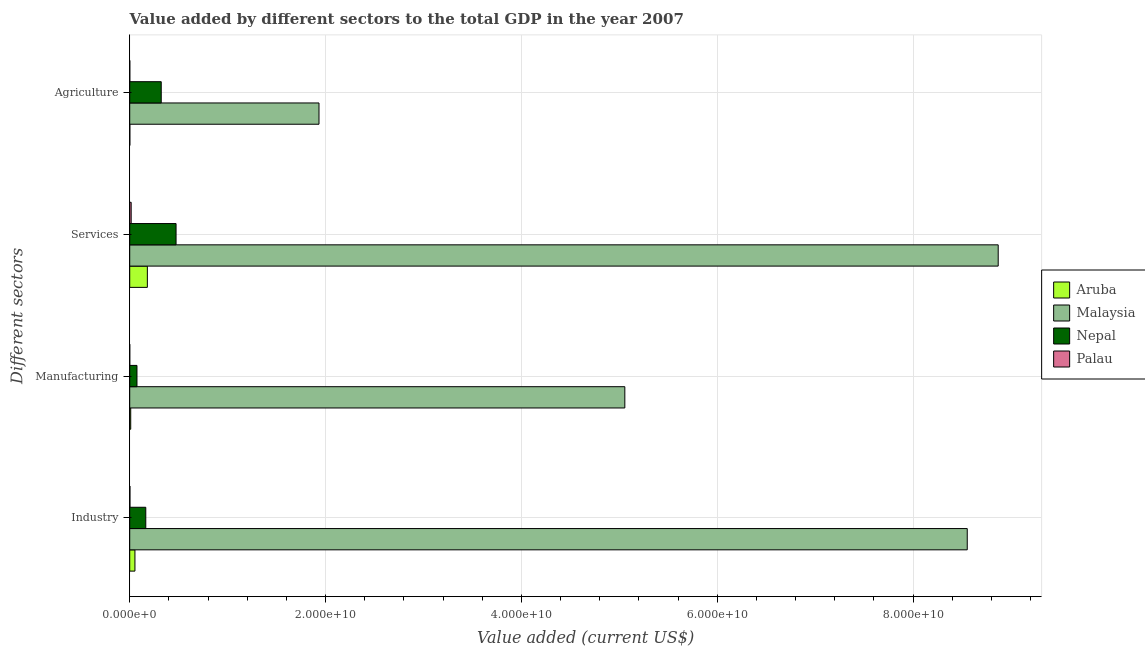How many different coloured bars are there?
Your answer should be very brief. 4. Are the number of bars per tick equal to the number of legend labels?
Make the answer very short. Yes. How many bars are there on the 3rd tick from the bottom?
Keep it short and to the point. 4. What is the label of the 2nd group of bars from the top?
Keep it short and to the point. Services. What is the value added by services sector in Malaysia?
Give a very brief answer. 8.87e+1. Across all countries, what is the maximum value added by industrial sector?
Keep it short and to the point. 8.55e+1. Across all countries, what is the minimum value added by agricultural sector?
Your answer should be compact. 7.87e+06. In which country was the value added by agricultural sector maximum?
Offer a very short reply. Malaysia. In which country was the value added by manufacturing sector minimum?
Provide a short and direct response. Palau. What is the total value added by services sector in the graph?
Your answer should be very brief. 9.54e+1. What is the difference between the value added by agricultural sector in Nepal and that in Palau?
Your response must be concise. 3.21e+09. What is the difference between the value added by services sector in Malaysia and the value added by industrial sector in Nepal?
Offer a terse response. 8.71e+1. What is the average value added by services sector per country?
Provide a succinct answer. 2.38e+1. What is the difference between the value added by agricultural sector and value added by manufacturing sector in Nepal?
Provide a succinct answer. 2.48e+09. What is the ratio of the value added by services sector in Aruba to that in Malaysia?
Provide a short and direct response. 0.02. Is the value added by manufacturing sector in Malaysia less than that in Nepal?
Make the answer very short. No. What is the difference between the highest and the second highest value added by services sector?
Provide a short and direct response. 8.40e+1. What is the difference between the highest and the lowest value added by agricultural sector?
Give a very brief answer. 1.93e+1. Is it the case that in every country, the sum of the value added by industrial sector and value added by manufacturing sector is greater than the sum of value added by services sector and value added by agricultural sector?
Offer a very short reply. No. What does the 2nd bar from the top in Industry represents?
Make the answer very short. Nepal. What does the 4th bar from the bottom in Manufacturing represents?
Provide a succinct answer. Palau. How many bars are there?
Keep it short and to the point. 16. What is the difference between two consecutive major ticks on the X-axis?
Offer a very short reply. 2.00e+1. Are the values on the major ticks of X-axis written in scientific E-notation?
Keep it short and to the point. Yes. Does the graph contain any zero values?
Offer a terse response. No. Does the graph contain grids?
Provide a succinct answer. Yes. Where does the legend appear in the graph?
Make the answer very short. Center right. How many legend labels are there?
Offer a very short reply. 4. What is the title of the graph?
Offer a very short reply. Value added by different sectors to the total GDP in the year 2007. What is the label or title of the X-axis?
Provide a succinct answer. Value added (current US$). What is the label or title of the Y-axis?
Provide a short and direct response. Different sectors. What is the Value added (current US$) of Aruba in Industry?
Provide a succinct answer. 5.32e+08. What is the Value added (current US$) of Malaysia in Industry?
Give a very brief answer. 8.55e+1. What is the Value added (current US$) of Nepal in Industry?
Provide a succinct answer. 1.64e+09. What is the Value added (current US$) of Palau in Industry?
Your answer should be compact. 2.17e+07. What is the Value added (current US$) in Aruba in Manufacturing?
Offer a very short reply. 1.01e+08. What is the Value added (current US$) in Malaysia in Manufacturing?
Your response must be concise. 5.06e+1. What is the Value added (current US$) in Nepal in Manufacturing?
Make the answer very short. 7.40e+08. What is the Value added (current US$) in Palau in Manufacturing?
Ensure brevity in your answer.  1.51e+06. What is the Value added (current US$) of Aruba in Services?
Offer a very short reply. 1.80e+09. What is the Value added (current US$) in Malaysia in Services?
Ensure brevity in your answer.  8.87e+1. What is the Value added (current US$) in Nepal in Services?
Provide a short and direct response. 4.73e+09. What is the Value added (current US$) of Palau in Services?
Provide a succinct answer. 1.47e+08. What is the Value added (current US$) in Aruba in Agriculture?
Provide a short and direct response. 1.05e+07. What is the Value added (current US$) in Malaysia in Agriculture?
Make the answer very short. 1.93e+1. What is the Value added (current US$) in Nepal in Agriculture?
Make the answer very short. 3.22e+09. What is the Value added (current US$) in Palau in Agriculture?
Make the answer very short. 7.87e+06. Across all Different sectors, what is the maximum Value added (current US$) in Aruba?
Make the answer very short. 1.80e+09. Across all Different sectors, what is the maximum Value added (current US$) in Malaysia?
Your answer should be very brief. 8.87e+1. Across all Different sectors, what is the maximum Value added (current US$) in Nepal?
Your answer should be very brief. 4.73e+09. Across all Different sectors, what is the maximum Value added (current US$) of Palau?
Your answer should be very brief. 1.47e+08. Across all Different sectors, what is the minimum Value added (current US$) in Aruba?
Your response must be concise. 1.05e+07. Across all Different sectors, what is the minimum Value added (current US$) in Malaysia?
Offer a terse response. 1.93e+1. Across all Different sectors, what is the minimum Value added (current US$) in Nepal?
Offer a very short reply. 7.40e+08. Across all Different sectors, what is the minimum Value added (current US$) in Palau?
Give a very brief answer. 1.51e+06. What is the total Value added (current US$) of Aruba in the graph?
Make the answer very short. 2.44e+09. What is the total Value added (current US$) of Malaysia in the graph?
Your answer should be compact. 2.44e+11. What is the total Value added (current US$) in Nepal in the graph?
Offer a terse response. 1.03e+1. What is the total Value added (current US$) in Palau in the graph?
Offer a very short reply. 1.79e+08. What is the difference between the Value added (current US$) in Aruba in Industry and that in Manufacturing?
Provide a short and direct response. 4.31e+08. What is the difference between the Value added (current US$) in Malaysia in Industry and that in Manufacturing?
Make the answer very short. 3.50e+1. What is the difference between the Value added (current US$) in Nepal in Industry and that in Manufacturing?
Your answer should be compact. 8.99e+08. What is the difference between the Value added (current US$) in Palau in Industry and that in Manufacturing?
Give a very brief answer. 2.02e+07. What is the difference between the Value added (current US$) of Aruba in Industry and that in Services?
Provide a succinct answer. -1.27e+09. What is the difference between the Value added (current US$) of Malaysia in Industry and that in Services?
Provide a short and direct response. -3.16e+09. What is the difference between the Value added (current US$) of Nepal in Industry and that in Services?
Provide a succinct answer. -3.09e+09. What is the difference between the Value added (current US$) in Palau in Industry and that in Services?
Make the answer very short. -1.26e+08. What is the difference between the Value added (current US$) in Aruba in Industry and that in Agriculture?
Offer a very short reply. 5.21e+08. What is the difference between the Value added (current US$) in Malaysia in Industry and that in Agriculture?
Offer a very short reply. 6.62e+1. What is the difference between the Value added (current US$) of Nepal in Industry and that in Agriculture?
Make the answer very short. -1.58e+09. What is the difference between the Value added (current US$) in Palau in Industry and that in Agriculture?
Provide a succinct answer. 1.38e+07. What is the difference between the Value added (current US$) in Aruba in Manufacturing and that in Services?
Offer a terse response. -1.70e+09. What is the difference between the Value added (current US$) of Malaysia in Manufacturing and that in Services?
Ensure brevity in your answer.  -3.81e+1. What is the difference between the Value added (current US$) in Nepal in Manufacturing and that in Services?
Make the answer very short. -3.99e+09. What is the difference between the Value added (current US$) of Palau in Manufacturing and that in Services?
Your answer should be compact. -1.46e+08. What is the difference between the Value added (current US$) of Aruba in Manufacturing and that in Agriculture?
Offer a terse response. 9.03e+07. What is the difference between the Value added (current US$) in Malaysia in Manufacturing and that in Agriculture?
Ensure brevity in your answer.  3.12e+1. What is the difference between the Value added (current US$) in Nepal in Manufacturing and that in Agriculture?
Offer a very short reply. -2.48e+09. What is the difference between the Value added (current US$) in Palau in Manufacturing and that in Agriculture?
Ensure brevity in your answer.  -6.36e+06. What is the difference between the Value added (current US$) of Aruba in Services and that in Agriculture?
Make the answer very short. 1.79e+09. What is the difference between the Value added (current US$) of Malaysia in Services and that in Agriculture?
Keep it short and to the point. 6.94e+1. What is the difference between the Value added (current US$) in Nepal in Services and that in Agriculture?
Provide a succinct answer. 1.51e+09. What is the difference between the Value added (current US$) in Palau in Services and that in Agriculture?
Provide a short and direct response. 1.40e+08. What is the difference between the Value added (current US$) of Aruba in Industry and the Value added (current US$) of Malaysia in Manufacturing?
Make the answer very short. -5.00e+1. What is the difference between the Value added (current US$) of Aruba in Industry and the Value added (current US$) of Nepal in Manufacturing?
Provide a short and direct response. -2.08e+08. What is the difference between the Value added (current US$) in Aruba in Industry and the Value added (current US$) in Palau in Manufacturing?
Your answer should be compact. 5.30e+08. What is the difference between the Value added (current US$) in Malaysia in Industry and the Value added (current US$) in Nepal in Manufacturing?
Your answer should be very brief. 8.48e+1. What is the difference between the Value added (current US$) in Malaysia in Industry and the Value added (current US$) in Palau in Manufacturing?
Provide a succinct answer. 8.55e+1. What is the difference between the Value added (current US$) of Nepal in Industry and the Value added (current US$) of Palau in Manufacturing?
Your answer should be compact. 1.64e+09. What is the difference between the Value added (current US$) of Aruba in Industry and the Value added (current US$) of Malaysia in Services?
Offer a terse response. -8.82e+1. What is the difference between the Value added (current US$) in Aruba in Industry and the Value added (current US$) in Nepal in Services?
Keep it short and to the point. -4.20e+09. What is the difference between the Value added (current US$) in Aruba in Industry and the Value added (current US$) in Palau in Services?
Make the answer very short. 3.84e+08. What is the difference between the Value added (current US$) in Malaysia in Industry and the Value added (current US$) in Nepal in Services?
Provide a succinct answer. 8.08e+1. What is the difference between the Value added (current US$) of Malaysia in Industry and the Value added (current US$) of Palau in Services?
Provide a succinct answer. 8.54e+1. What is the difference between the Value added (current US$) of Nepal in Industry and the Value added (current US$) of Palau in Services?
Your response must be concise. 1.49e+09. What is the difference between the Value added (current US$) of Aruba in Industry and the Value added (current US$) of Malaysia in Agriculture?
Offer a very short reply. -1.88e+1. What is the difference between the Value added (current US$) of Aruba in Industry and the Value added (current US$) of Nepal in Agriculture?
Your response must be concise. -2.69e+09. What is the difference between the Value added (current US$) in Aruba in Industry and the Value added (current US$) in Palau in Agriculture?
Your answer should be very brief. 5.24e+08. What is the difference between the Value added (current US$) of Malaysia in Industry and the Value added (current US$) of Nepal in Agriculture?
Your response must be concise. 8.23e+1. What is the difference between the Value added (current US$) of Malaysia in Industry and the Value added (current US$) of Palau in Agriculture?
Offer a very short reply. 8.55e+1. What is the difference between the Value added (current US$) in Nepal in Industry and the Value added (current US$) in Palau in Agriculture?
Your answer should be very brief. 1.63e+09. What is the difference between the Value added (current US$) in Aruba in Manufacturing and the Value added (current US$) in Malaysia in Services?
Provide a succinct answer. -8.86e+1. What is the difference between the Value added (current US$) in Aruba in Manufacturing and the Value added (current US$) in Nepal in Services?
Offer a very short reply. -4.63e+09. What is the difference between the Value added (current US$) in Aruba in Manufacturing and the Value added (current US$) in Palau in Services?
Offer a terse response. -4.67e+07. What is the difference between the Value added (current US$) of Malaysia in Manufacturing and the Value added (current US$) of Nepal in Services?
Offer a terse response. 4.58e+1. What is the difference between the Value added (current US$) in Malaysia in Manufacturing and the Value added (current US$) in Palau in Services?
Offer a very short reply. 5.04e+1. What is the difference between the Value added (current US$) in Nepal in Manufacturing and the Value added (current US$) in Palau in Services?
Ensure brevity in your answer.  5.93e+08. What is the difference between the Value added (current US$) of Aruba in Manufacturing and the Value added (current US$) of Malaysia in Agriculture?
Offer a very short reply. -1.92e+1. What is the difference between the Value added (current US$) of Aruba in Manufacturing and the Value added (current US$) of Nepal in Agriculture?
Provide a short and direct response. -3.12e+09. What is the difference between the Value added (current US$) in Aruba in Manufacturing and the Value added (current US$) in Palau in Agriculture?
Offer a very short reply. 9.29e+07. What is the difference between the Value added (current US$) of Malaysia in Manufacturing and the Value added (current US$) of Nepal in Agriculture?
Offer a terse response. 4.73e+1. What is the difference between the Value added (current US$) in Malaysia in Manufacturing and the Value added (current US$) in Palau in Agriculture?
Make the answer very short. 5.06e+1. What is the difference between the Value added (current US$) in Nepal in Manufacturing and the Value added (current US$) in Palau in Agriculture?
Ensure brevity in your answer.  7.32e+08. What is the difference between the Value added (current US$) of Aruba in Services and the Value added (current US$) of Malaysia in Agriculture?
Ensure brevity in your answer.  -1.75e+1. What is the difference between the Value added (current US$) of Aruba in Services and the Value added (current US$) of Nepal in Agriculture?
Provide a short and direct response. -1.42e+09. What is the difference between the Value added (current US$) in Aruba in Services and the Value added (current US$) in Palau in Agriculture?
Make the answer very short. 1.79e+09. What is the difference between the Value added (current US$) of Malaysia in Services and the Value added (current US$) of Nepal in Agriculture?
Keep it short and to the point. 8.55e+1. What is the difference between the Value added (current US$) of Malaysia in Services and the Value added (current US$) of Palau in Agriculture?
Offer a terse response. 8.87e+1. What is the difference between the Value added (current US$) of Nepal in Services and the Value added (current US$) of Palau in Agriculture?
Offer a terse response. 4.72e+09. What is the average Value added (current US$) in Aruba per Different sectors?
Your response must be concise. 6.11e+08. What is the average Value added (current US$) in Malaysia per Different sectors?
Your response must be concise. 6.10e+1. What is the average Value added (current US$) in Nepal per Different sectors?
Your answer should be very brief. 2.58e+09. What is the average Value added (current US$) in Palau per Different sectors?
Provide a succinct answer. 4.46e+07. What is the difference between the Value added (current US$) in Aruba and Value added (current US$) in Malaysia in Industry?
Your response must be concise. -8.50e+1. What is the difference between the Value added (current US$) of Aruba and Value added (current US$) of Nepal in Industry?
Ensure brevity in your answer.  -1.11e+09. What is the difference between the Value added (current US$) of Aruba and Value added (current US$) of Palau in Industry?
Make the answer very short. 5.10e+08. What is the difference between the Value added (current US$) of Malaysia and Value added (current US$) of Nepal in Industry?
Give a very brief answer. 8.39e+1. What is the difference between the Value added (current US$) in Malaysia and Value added (current US$) in Palau in Industry?
Keep it short and to the point. 8.55e+1. What is the difference between the Value added (current US$) of Nepal and Value added (current US$) of Palau in Industry?
Make the answer very short. 1.62e+09. What is the difference between the Value added (current US$) in Aruba and Value added (current US$) in Malaysia in Manufacturing?
Your response must be concise. -5.05e+1. What is the difference between the Value added (current US$) of Aruba and Value added (current US$) of Nepal in Manufacturing?
Provide a short and direct response. -6.39e+08. What is the difference between the Value added (current US$) of Aruba and Value added (current US$) of Palau in Manufacturing?
Give a very brief answer. 9.93e+07. What is the difference between the Value added (current US$) of Malaysia and Value added (current US$) of Nepal in Manufacturing?
Your answer should be compact. 4.98e+1. What is the difference between the Value added (current US$) in Malaysia and Value added (current US$) in Palau in Manufacturing?
Ensure brevity in your answer.  5.06e+1. What is the difference between the Value added (current US$) in Nepal and Value added (current US$) in Palau in Manufacturing?
Give a very brief answer. 7.39e+08. What is the difference between the Value added (current US$) in Aruba and Value added (current US$) in Malaysia in Services?
Provide a short and direct response. -8.69e+1. What is the difference between the Value added (current US$) of Aruba and Value added (current US$) of Nepal in Services?
Your answer should be very brief. -2.93e+09. What is the difference between the Value added (current US$) of Aruba and Value added (current US$) of Palau in Services?
Your answer should be very brief. 1.65e+09. What is the difference between the Value added (current US$) in Malaysia and Value added (current US$) in Nepal in Services?
Your answer should be very brief. 8.40e+1. What is the difference between the Value added (current US$) in Malaysia and Value added (current US$) in Palau in Services?
Your answer should be compact. 8.85e+1. What is the difference between the Value added (current US$) in Nepal and Value added (current US$) in Palau in Services?
Offer a very short reply. 4.58e+09. What is the difference between the Value added (current US$) in Aruba and Value added (current US$) in Malaysia in Agriculture?
Your answer should be very brief. -1.93e+1. What is the difference between the Value added (current US$) in Aruba and Value added (current US$) in Nepal in Agriculture?
Make the answer very short. -3.21e+09. What is the difference between the Value added (current US$) of Aruba and Value added (current US$) of Palau in Agriculture?
Offer a very short reply. 2.67e+06. What is the difference between the Value added (current US$) in Malaysia and Value added (current US$) in Nepal in Agriculture?
Offer a very short reply. 1.61e+1. What is the difference between the Value added (current US$) of Malaysia and Value added (current US$) of Palau in Agriculture?
Your answer should be very brief. 1.93e+1. What is the difference between the Value added (current US$) of Nepal and Value added (current US$) of Palau in Agriculture?
Your response must be concise. 3.21e+09. What is the ratio of the Value added (current US$) of Aruba in Industry to that in Manufacturing?
Ensure brevity in your answer.  5.28. What is the ratio of the Value added (current US$) in Malaysia in Industry to that in Manufacturing?
Ensure brevity in your answer.  1.69. What is the ratio of the Value added (current US$) in Nepal in Industry to that in Manufacturing?
Your answer should be very brief. 2.21. What is the ratio of the Value added (current US$) in Palau in Industry to that in Manufacturing?
Give a very brief answer. 14.41. What is the ratio of the Value added (current US$) of Aruba in Industry to that in Services?
Make the answer very short. 0.3. What is the ratio of the Value added (current US$) of Malaysia in Industry to that in Services?
Your response must be concise. 0.96. What is the ratio of the Value added (current US$) of Nepal in Industry to that in Services?
Your answer should be compact. 0.35. What is the ratio of the Value added (current US$) of Palau in Industry to that in Services?
Provide a short and direct response. 0.15. What is the ratio of the Value added (current US$) in Aruba in Industry to that in Agriculture?
Your answer should be very brief. 50.48. What is the ratio of the Value added (current US$) of Malaysia in Industry to that in Agriculture?
Your answer should be very brief. 4.42. What is the ratio of the Value added (current US$) in Nepal in Industry to that in Agriculture?
Make the answer very short. 0.51. What is the ratio of the Value added (current US$) in Palau in Industry to that in Agriculture?
Your response must be concise. 2.76. What is the ratio of the Value added (current US$) of Aruba in Manufacturing to that in Services?
Your answer should be very brief. 0.06. What is the ratio of the Value added (current US$) in Malaysia in Manufacturing to that in Services?
Offer a terse response. 0.57. What is the ratio of the Value added (current US$) of Nepal in Manufacturing to that in Services?
Provide a succinct answer. 0.16. What is the ratio of the Value added (current US$) in Palau in Manufacturing to that in Services?
Give a very brief answer. 0.01. What is the ratio of the Value added (current US$) in Aruba in Manufacturing to that in Agriculture?
Provide a succinct answer. 9.57. What is the ratio of the Value added (current US$) of Malaysia in Manufacturing to that in Agriculture?
Your response must be concise. 2.62. What is the ratio of the Value added (current US$) in Nepal in Manufacturing to that in Agriculture?
Provide a succinct answer. 0.23. What is the ratio of the Value added (current US$) in Palau in Manufacturing to that in Agriculture?
Make the answer very short. 0.19. What is the ratio of the Value added (current US$) in Aruba in Services to that in Agriculture?
Provide a short and direct response. 170.98. What is the ratio of the Value added (current US$) in Malaysia in Services to that in Agriculture?
Keep it short and to the point. 4.59. What is the ratio of the Value added (current US$) in Nepal in Services to that in Agriculture?
Offer a very short reply. 1.47. What is the ratio of the Value added (current US$) in Palau in Services to that in Agriculture?
Offer a terse response. 18.74. What is the difference between the highest and the second highest Value added (current US$) of Aruba?
Provide a succinct answer. 1.27e+09. What is the difference between the highest and the second highest Value added (current US$) in Malaysia?
Make the answer very short. 3.16e+09. What is the difference between the highest and the second highest Value added (current US$) of Nepal?
Your answer should be compact. 1.51e+09. What is the difference between the highest and the second highest Value added (current US$) in Palau?
Provide a short and direct response. 1.26e+08. What is the difference between the highest and the lowest Value added (current US$) of Aruba?
Offer a terse response. 1.79e+09. What is the difference between the highest and the lowest Value added (current US$) in Malaysia?
Keep it short and to the point. 6.94e+1. What is the difference between the highest and the lowest Value added (current US$) of Nepal?
Provide a succinct answer. 3.99e+09. What is the difference between the highest and the lowest Value added (current US$) in Palau?
Make the answer very short. 1.46e+08. 